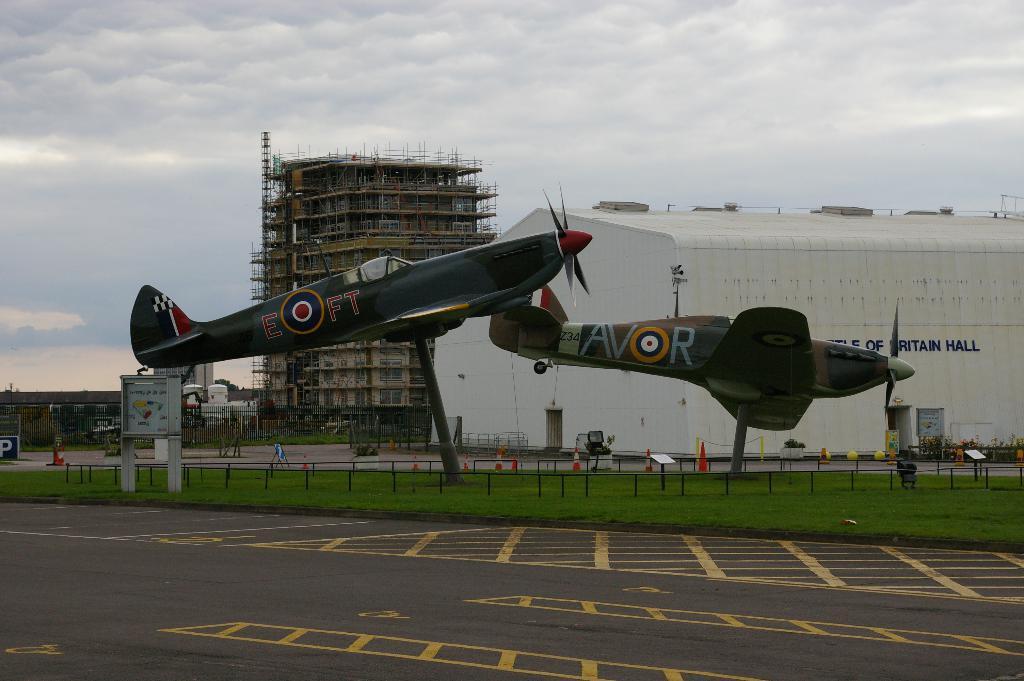Please provide a concise description of this image. At the bottom of the image there is a road. Behind the road on the ground there is grass and also there is fencing. In between the fencing there are statues of planes. Behind the grass there are traffic cones. In the background there is a building with walls, roof and text on it. And also there is a construction of building and there are few trees and fencing. At the top of the image there is sky with clouds. 